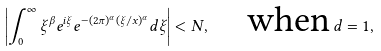<formula> <loc_0><loc_0><loc_500><loc_500>\left | \int ^ { \infty } _ { 0 } \xi ^ { \beta } e ^ { i \xi } e ^ { - ( 2 \pi ) ^ { \alpha } ( \xi / x ) ^ { \alpha } } d \xi \right | < N , \quad \text {when} \, d = 1 ,</formula> 